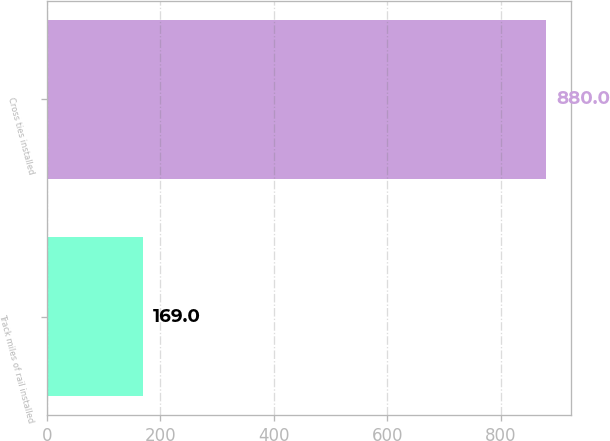Convert chart. <chart><loc_0><loc_0><loc_500><loc_500><bar_chart><fcel>Track miles of rail installed<fcel>Cross ties installed<nl><fcel>169<fcel>880<nl></chart> 